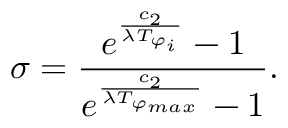Convert formula to latex. <formula><loc_0><loc_0><loc_500><loc_500>\sigma = \frac { e ^ { \frac { c _ { 2 } } { \lambda T _ { \varphi _ { i } } } } - 1 } { e ^ { \frac { c _ { 2 } } { \lambda T _ { \varphi _ { \max } } } } - 1 } .</formula> 